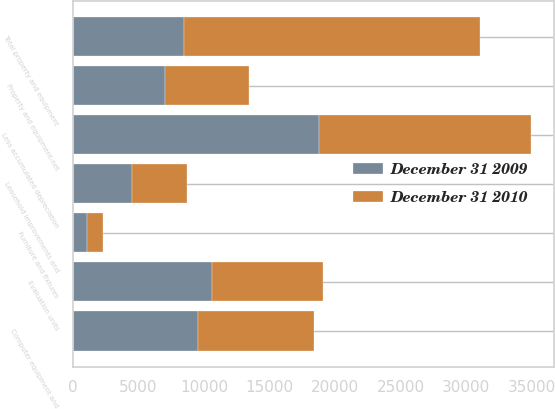Convert chart to OTSL. <chart><loc_0><loc_0><loc_500><loc_500><stacked_bar_chart><ecel><fcel>Evaluation units<fcel>Computer equipment and<fcel>Furniture and fixtures<fcel>Leasehold improvements and<fcel>Total property and equipment<fcel>Less accumulated depreciation<fcel>Property and equipment-net<nl><fcel>December 31 2009<fcel>10607<fcel>9561<fcel>1087<fcel>4548<fcel>8449<fcel>18747<fcel>7056<nl><fcel>December 31 2010<fcel>8449<fcel>8827<fcel>1191<fcel>4134<fcel>22601<fcel>16214<fcel>6387<nl></chart> 